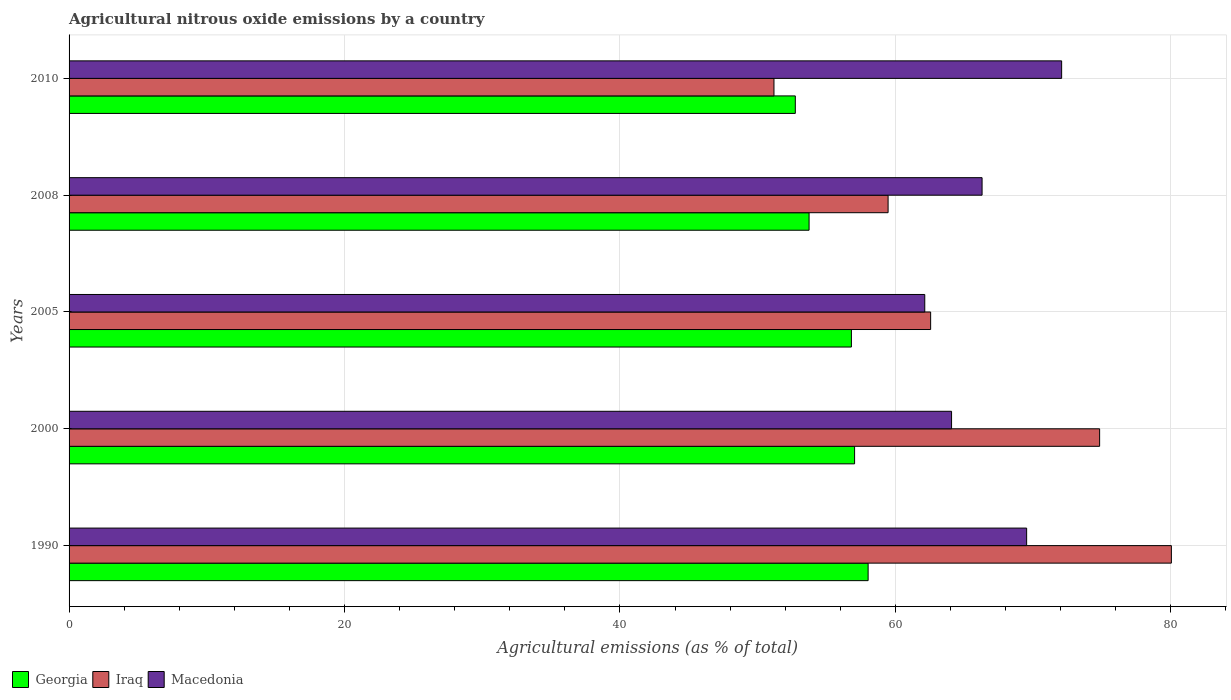How many groups of bars are there?
Keep it short and to the point. 5. Are the number of bars per tick equal to the number of legend labels?
Ensure brevity in your answer.  Yes. Are the number of bars on each tick of the Y-axis equal?
Keep it short and to the point. Yes. How many bars are there on the 3rd tick from the top?
Your answer should be compact. 3. How many bars are there on the 2nd tick from the bottom?
Ensure brevity in your answer.  3. What is the label of the 1st group of bars from the top?
Ensure brevity in your answer.  2010. What is the amount of agricultural nitrous oxide emitted in Iraq in 2000?
Offer a very short reply. 74.83. Across all years, what is the maximum amount of agricultural nitrous oxide emitted in Macedonia?
Make the answer very short. 72.07. Across all years, what is the minimum amount of agricultural nitrous oxide emitted in Macedonia?
Provide a succinct answer. 62.13. What is the total amount of agricultural nitrous oxide emitted in Georgia in the graph?
Your answer should be compact. 278.33. What is the difference between the amount of agricultural nitrous oxide emitted in Macedonia in 2000 and that in 2010?
Your answer should be very brief. -7.99. What is the difference between the amount of agricultural nitrous oxide emitted in Iraq in 2010 and the amount of agricultural nitrous oxide emitted in Georgia in 2000?
Offer a terse response. -5.85. What is the average amount of agricultural nitrous oxide emitted in Iraq per year?
Make the answer very short. 65.62. In the year 2000, what is the difference between the amount of agricultural nitrous oxide emitted in Georgia and amount of agricultural nitrous oxide emitted in Macedonia?
Provide a short and direct response. -7.04. In how many years, is the amount of agricultural nitrous oxide emitted in Macedonia greater than 56 %?
Keep it short and to the point. 5. What is the ratio of the amount of agricultural nitrous oxide emitted in Macedonia in 1990 to that in 2010?
Your answer should be very brief. 0.96. Is the amount of agricultural nitrous oxide emitted in Iraq in 1990 less than that in 2008?
Your response must be concise. No. What is the difference between the highest and the second highest amount of agricultural nitrous oxide emitted in Iraq?
Provide a succinct answer. 5.21. What is the difference between the highest and the lowest amount of agricultural nitrous oxide emitted in Iraq?
Offer a very short reply. 28.86. What does the 3rd bar from the top in 2000 represents?
Your answer should be compact. Georgia. What does the 2nd bar from the bottom in 2008 represents?
Your response must be concise. Iraq. How many bars are there?
Give a very brief answer. 15. Are all the bars in the graph horizontal?
Provide a short and direct response. Yes. Where does the legend appear in the graph?
Make the answer very short. Bottom left. How many legend labels are there?
Provide a succinct answer. 3. What is the title of the graph?
Your answer should be compact. Agricultural nitrous oxide emissions by a country. What is the label or title of the X-axis?
Offer a very short reply. Agricultural emissions (as % of total). What is the Agricultural emissions (as % of total) of Georgia in 1990?
Keep it short and to the point. 58.02. What is the Agricultural emissions (as % of total) in Iraq in 1990?
Keep it short and to the point. 80.04. What is the Agricultural emissions (as % of total) in Macedonia in 1990?
Give a very brief answer. 69.53. What is the Agricultural emissions (as % of total) in Georgia in 2000?
Provide a short and direct response. 57.04. What is the Agricultural emissions (as % of total) of Iraq in 2000?
Your answer should be compact. 74.83. What is the Agricultural emissions (as % of total) of Macedonia in 2000?
Provide a short and direct response. 64.08. What is the Agricultural emissions (as % of total) of Georgia in 2005?
Keep it short and to the point. 56.81. What is the Agricultural emissions (as % of total) of Iraq in 2005?
Give a very brief answer. 62.56. What is the Agricultural emissions (as % of total) of Macedonia in 2005?
Ensure brevity in your answer.  62.13. What is the Agricultural emissions (as % of total) in Georgia in 2008?
Provide a succinct answer. 53.73. What is the Agricultural emissions (as % of total) in Iraq in 2008?
Your response must be concise. 59.47. What is the Agricultural emissions (as % of total) in Macedonia in 2008?
Give a very brief answer. 66.29. What is the Agricultural emissions (as % of total) of Georgia in 2010?
Ensure brevity in your answer.  52.73. What is the Agricultural emissions (as % of total) of Iraq in 2010?
Your response must be concise. 51.18. What is the Agricultural emissions (as % of total) in Macedonia in 2010?
Offer a very short reply. 72.07. Across all years, what is the maximum Agricultural emissions (as % of total) in Georgia?
Provide a succinct answer. 58.02. Across all years, what is the maximum Agricultural emissions (as % of total) of Iraq?
Offer a very short reply. 80.04. Across all years, what is the maximum Agricultural emissions (as % of total) in Macedonia?
Ensure brevity in your answer.  72.07. Across all years, what is the minimum Agricultural emissions (as % of total) in Georgia?
Provide a short and direct response. 52.73. Across all years, what is the minimum Agricultural emissions (as % of total) in Iraq?
Your response must be concise. 51.18. Across all years, what is the minimum Agricultural emissions (as % of total) of Macedonia?
Offer a very short reply. 62.13. What is the total Agricultural emissions (as % of total) of Georgia in the graph?
Provide a short and direct response. 278.33. What is the total Agricultural emissions (as % of total) in Iraq in the graph?
Provide a short and direct response. 328.08. What is the total Agricultural emissions (as % of total) of Macedonia in the graph?
Your answer should be very brief. 334.11. What is the difference between the Agricultural emissions (as % of total) in Georgia in 1990 and that in 2000?
Your answer should be compact. 0.98. What is the difference between the Agricultural emissions (as % of total) in Iraq in 1990 and that in 2000?
Give a very brief answer. 5.21. What is the difference between the Agricultural emissions (as % of total) of Macedonia in 1990 and that in 2000?
Your answer should be compact. 5.45. What is the difference between the Agricultural emissions (as % of total) in Georgia in 1990 and that in 2005?
Offer a very short reply. 1.21. What is the difference between the Agricultural emissions (as % of total) in Iraq in 1990 and that in 2005?
Offer a very short reply. 17.48. What is the difference between the Agricultural emissions (as % of total) in Macedonia in 1990 and that in 2005?
Provide a short and direct response. 7.4. What is the difference between the Agricultural emissions (as % of total) in Georgia in 1990 and that in 2008?
Make the answer very short. 4.29. What is the difference between the Agricultural emissions (as % of total) of Iraq in 1990 and that in 2008?
Give a very brief answer. 20.57. What is the difference between the Agricultural emissions (as % of total) of Macedonia in 1990 and that in 2008?
Make the answer very short. 3.24. What is the difference between the Agricultural emissions (as % of total) in Georgia in 1990 and that in 2010?
Your answer should be very brief. 5.29. What is the difference between the Agricultural emissions (as % of total) in Iraq in 1990 and that in 2010?
Your response must be concise. 28.86. What is the difference between the Agricultural emissions (as % of total) in Macedonia in 1990 and that in 2010?
Provide a succinct answer. -2.54. What is the difference between the Agricultural emissions (as % of total) in Georgia in 2000 and that in 2005?
Your response must be concise. 0.23. What is the difference between the Agricultural emissions (as % of total) of Iraq in 2000 and that in 2005?
Provide a short and direct response. 12.27. What is the difference between the Agricultural emissions (as % of total) in Macedonia in 2000 and that in 2005?
Your response must be concise. 1.95. What is the difference between the Agricultural emissions (as % of total) in Georgia in 2000 and that in 2008?
Keep it short and to the point. 3.3. What is the difference between the Agricultural emissions (as % of total) of Iraq in 2000 and that in 2008?
Give a very brief answer. 15.36. What is the difference between the Agricultural emissions (as % of total) in Macedonia in 2000 and that in 2008?
Your answer should be compact. -2.22. What is the difference between the Agricultural emissions (as % of total) in Georgia in 2000 and that in 2010?
Keep it short and to the point. 4.3. What is the difference between the Agricultural emissions (as % of total) of Iraq in 2000 and that in 2010?
Your response must be concise. 23.65. What is the difference between the Agricultural emissions (as % of total) in Macedonia in 2000 and that in 2010?
Keep it short and to the point. -7.99. What is the difference between the Agricultural emissions (as % of total) of Georgia in 2005 and that in 2008?
Keep it short and to the point. 3.07. What is the difference between the Agricultural emissions (as % of total) of Iraq in 2005 and that in 2008?
Give a very brief answer. 3.09. What is the difference between the Agricultural emissions (as % of total) of Macedonia in 2005 and that in 2008?
Give a very brief answer. -4.16. What is the difference between the Agricultural emissions (as % of total) of Georgia in 2005 and that in 2010?
Give a very brief answer. 4.07. What is the difference between the Agricultural emissions (as % of total) in Iraq in 2005 and that in 2010?
Give a very brief answer. 11.38. What is the difference between the Agricultural emissions (as % of total) of Macedonia in 2005 and that in 2010?
Provide a short and direct response. -9.94. What is the difference between the Agricultural emissions (as % of total) in Georgia in 2008 and that in 2010?
Offer a terse response. 1. What is the difference between the Agricultural emissions (as % of total) of Iraq in 2008 and that in 2010?
Your answer should be compact. 8.29. What is the difference between the Agricultural emissions (as % of total) in Macedonia in 2008 and that in 2010?
Offer a terse response. -5.78. What is the difference between the Agricultural emissions (as % of total) of Georgia in 1990 and the Agricultural emissions (as % of total) of Iraq in 2000?
Give a very brief answer. -16.81. What is the difference between the Agricultural emissions (as % of total) of Georgia in 1990 and the Agricultural emissions (as % of total) of Macedonia in 2000?
Your response must be concise. -6.06. What is the difference between the Agricultural emissions (as % of total) in Iraq in 1990 and the Agricultural emissions (as % of total) in Macedonia in 2000?
Provide a succinct answer. 15.96. What is the difference between the Agricultural emissions (as % of total) of Georgia in 1990 and the Agricultural emissions (as % of total) of Iraq in 2005?
Your answer should be very brief. -4.54. What is the difference between the Agricultural emissions (as % of total) in Georgia in 1990 and the Agricultural emissions (as % of total) in Macedonia in 2005?
Your response must be concise. -4.11. What is the difference between the Agricultural emissions (as % of total) in Iraq in 1990 and the Agricultural emissions (as % of total) in Macedonia in 2005?
Provide a short and direct response. 17.91. What is the difference between the Agricultural emissions (as % of total) in Georgia in 1990 and the Agricultural emissions (as % of total) in Iraq in 2008?
Keep it short and to the point. -1.45. What is the difference between the Agricultural emissions (as % of total) in Georgia in 1990 and the Agricultural emissions (as % of total) in Macedonia in 2008?
Your answer should be compact. -8.28. What is the difference between the Agricultural emissions (as % of total) of Iraq in 1990 and the Agricultural emissions (as % of total) of Macedonia in 2008?
Give a very brief answer. 13.74. What is the difference between the Agricultural emissions (as % of total) of Georgia in 1990 and the Agricultural emissions (as % of total) of Iraq in 2010?
Provide a succinct answer. 6.84. What is the difference between the Agricultural emissions (as % of total) of Georgia in 1990 and the Agricultural emissions (as % of total) of Macedonia in 2010?
Offer a terse response. -14.05. What is the difference between the Agricultural emissions (as % of total) of Iraq in 1990 and the Agricultural emissions (as % of total) of Macedonia in 2010?
Offer a very short reply. 7.97. What is the difference between the Agricultural emissions (as % of total) in Georgia in 2000 and the Agricultural emissions (as % of total) in Iraq in 2005?
Make the answer very short. -5.52. What is the difference between the Agricultural emissions (as % of total) in Georgia in 2000 and the Agricultural emissions (as % of total) in Macedonia in 2005?
Make the answer very short. -5.1. What is the difference between the Agricultural emissions (as % of total) of Iraq in 2000 and the Agricultural emissions (as % of total) of Macedonia in 2005?
Make the answer very short. 12.7. What is the difference between the Agricultural emissions (as % of total) of Georgia in 2000 and the Agricultural emissions (as % of total) of Iraq in 2008?
Provide a short and direct response. -2.43. What is the difference between the Agricultural emissions (as % of total) of Georgia in 2000 and the Agricultural emissions (as % of total) of Macedonia in 2008?
Your answer should be very brief. -9.26. What is the difference between the Agricultural emissions (as % of total) of Iraq in 2000 and the Agricultural emissions (as % of total) of Macedonia in 2008?
Provide a short and direct response. 8.53. What is the difference between the Agricultural emissions (as % of total) of Georgia in 2000 and the Agricultural emissions (as % of total) of Iraq in 2010?
Offer a very short reply. 5.85. What is the difference between the Agricultural emissions (as % of total) in Georgia in 2000 and the Agricultural emissions (as % of total) in Macedonia in 2010?
Your response must be concise. -15.03. What is the difference between the Agricultural emissions (as % of total) in Iraq in 2000 and the Agricultural emissions (as % of total) in Macedonia in 2010?
Provide a succinct answer. 2.76. What is the difference between the Agricultural emissions (as % of total) of Georgia in 2005 and the Agricultural emissions (as % of total) of Iraq in 2008?
Make the answer very short. -2.66. What is the difference between the Agricultural emissions (as % of total) of Georgia in 2005 and the Agricultural emissions (as % of total) of Macedonia in 2008?
Your answer should be compact. -9.49. What is the difference between the Agricultural emissions (as % of total) of Iraq in 2005 and the Agricultural emissions (as % of total) of Macedonia in 2008?
Your answer should be very brief. -3.74. What is the difference between the Agricultural emissions (as % of total) of Georgia in 2005 and the Agricultural emissions (as % of total) of Iraq in 2010?
Your answer should be compact. 5.62. What is the difference between the Agricultural emissions (as % of total) of Georgia in 2005 and the Agricultural emissions (as % of total) of Macedonia in 2010?
Your response must be concise. -15.27. What is the difference between the Agricultural emissions (as % of total) in Iraq in 2005 and the Agricultural emissions (as % of total) in Macedonia in 2010?
Offer a terse response. -9.51. What is the difference between the Agricultural emissions (as % of total) in Georgia in 2008 and the Agricultural emissions (as % of total) in Iraq in 2010?
Provide a succinct answer. 2.55. What is the difference between the Agricultural emissions (as % of total) of Georgia in 2008 and the Agricultural emissions (as % of total) of Macedonia in 2010?
Keep it short and to the point. -18.34. What is the difference between the Agricultural emissions (as % of total) in Iraq in 2008 and the Agricultural emissions (as % of total) in Macedonia in 2010?
Your response must be concise. -12.6. What is the average Agricultural emissions (as % of total) in Georgia per year?
Offer a very short reply. 55.67. What is the average Agricultural emissions (as % of total) of Iraq per year?
Give a very brief answer. 65.62. What is the average Agricultural emissions (as % of total) of Macedonia per year?
Offer a very short reply. 66.82. In the year 1990, what is the difference between the Agricultural emissions (as % of total) in Georgia and Agricultural emissions (as % of total) in Iraq?
Make the answer very short. -22.02. In the year 1990, what is the difference between the Agricultural emissions (as % of total) of Georgia and Agricultural emissions (as % of total) of Macedonia?
Keep it short and to the point. -11.51. In the year 1990, what is the difference between the Agricultural emissions (as % of total) of Iraq and Agricultural emissions (as % of total) of Macedonia?
Provide a succinct answer. 10.51. In the year 2000, what is the difference between the Agricultural emissions (as % of total) of Georgia and Agricultural emissions (as % of total) of Iraq?
Provide a short and direct response. -17.79. In the year 2000, what is the difference between the Agricultural emissions (as % of total) of Georgia and Agricultural emissions (as % of total) of Macedonia?
Your answer should be very brief. -7.04. In the year 2000, what is the difference between the Agricultural emissions (as % of total) of Iraq and Agricultural emissions (as % of total) of Macedonia?
Provide a short and direct response. 10.75. In the year 2005, what is the difference between the Agricultural emissions (as % of total) of Georgia and Agricultural emissions (as % of total) of Iraq?
Provide a short and direct response. -5.75. In the year 2005, what is the difference between the Agricultural emissions (as % of total) in Georgia and Agricultural emissions (as % of total) in Macedonia?
Make the answer very short. -5.33. In the year 2005, what is the difference between the Agricultural emissions (as % of total) of Iraq and Agricultural emissions (as % of total) of Macedonia?
Your response must be concise. 0.43. In the year 2008, what is the difference between the Agricultural emissions (as % of total) of Georgia and Agricultural emissions (as % of total) of Iraq?
Ensure brevity in your answer.  -5.74. In the year 2008, what is the difference between the Agricultural emissions (as % of total) in Georgia and Agricultural emissions (as % of total) in Macedonia?
Keep it short and to the point. -12.56. In the year 2008, what is the difference between the Agricultural emissions (as % of total) in Iraq and Agricultural emissions (as % of total) in Macedonia?
Offer a terse response. -6.82. In the year 2010, what is the difference between the Agricultural emissions (as % of total) of Georgia and Agricultural emissions (as % of total) of Iraq?
Offer a very short reply. 1.55. In the year 2010, what is the difference between the Agricultural emissions (as % of total) of Georgia and Agricultural emissions (as % of total) of Macedonia?
Give a very brief answer. -19.34. In the year 2010, what is the difference between the Agricultural emissions (as % of total) of Iraq and Agricultural emissions (as % of total) of Macedonia?
Your response must be concise. -20.89. What is the ratio of the Agricultural emissions (as % of total) of Georgia in 1990 to that in 2000?
Offer a terse response. 1.02. What is the ratio of the Agricultural emissions (as % of total) of Iraq in 1990 to that in 2000?
Ensure brevity in your answer.  1.07. What is the ratio of the Agricultural emissions (as % of total) of Macedonia in 1990 to that in 2000?
Give a very brief answer. 1.09. What is the ratio of the Agricultural emissions (as % of total) in Georgia in 1990 to that in 2005?
Offer a very short reply. 1.02. What is the ratio of the Agricultural emissions (as % of total) in Iraq in 1990 to that in 2005?
Keep it short and to the point. 1.28. What is the ratio of the Agricultural emissions (as % of total) in Macedonia in 1990 to that in 2005?
Your response must be concise. 1.12. What is the ratio of the Agricultural emissions (as % of total) in Georgia in 1990 to that in 2008?
Provide a short and direct response. 1.08. What is the ratio of the Agricultural emissions (as % of total) in Iraq in 1990 to that in 2008?
Provide a succinct answer. 1.35. What is the ratio of the Agricultural emissions (as % of total) of Macedonia in 1990 to that in 2008?
Ensure brevity in your answer.  1.05. What is the ratio of the Agricultural emissions (as % of total) of Georgia in 1990 to that in 2010?
Offer a terse response. 1.1. What is the ratio of the Agricultural emissions (as % of total) of Iraq in 1990 to that in 2010?
Provide a succinct answer. 1.56. What is the ratio of the Agricultural emissions (as % of total) in Macedonia in 1990 to that in 2010?
Provide a succinct answer. 0.96. What is the ratio of the Agricultural emissions (as % of total) in Georgia in 2000 to that in 2005?
Your answer should be very brief. 1. What is the ratio of the Agricultural emissions (as % of total) in Iraq in 2000 to that in 2005?
Ensure brevity in your answer.  1.2. What is the ratio of the Agricultural emissions (as % of total) in Macedonia in 2000 to that in 2005?
Give a very brief answer. 1.03. What is the ratio of the Agricultural emissions (as % of total) of Georgia in 2000 to that in 2008?
Offer a very short reply. 1.06. What is the ratio of the Agricultural emissions (as % of total) in Iraq in 2000 to that in 2008?
Your response must be concise. 1.26. What is the ratio of the Agricultural emissions (as % of total) of Macedonia in 2000 to that in 2008?
Keep it short and to the point. 0.97. What is the ratio of the Agricultural emissions (as % of total) in Georgia in 2000 to that in 2010?
Give a very brief answer. 1.08. What is the ratio of the Agricultural emissions (as % of total) of Iraq in 2000 to that in 2010?
Provide a short and direct response. 1.46. What is the ratio of the Agricultural emissions (as % of total) of Macedonia in 2000 to that in 2010?
Give a very brief answer. 0.89. What is the ratio of the Agricultural emissions (as % of total) of Georgia in 2005 to that in 2008?
Provide a short and direct response. 1.06. What is the ratio of the Agricultural emissions (as % of total) in Iraq in 2005 to that in 2008?
Offer a very short reply. 1.05. What is the ratio of the Agricultural emissions (as % of total) in Macedonia in 2005 to that in 2008?
Your answer should be very brief. 0.94. What is the ratio of the Agricultural emissions (as % of total) in Georgia in 2005 to that in 2010?
Offer a terse response. 1.08. What is the ratio of the Agricultural emissions (as % of total) of Iraq in 2005 to that in 2010?
Your answer should be compact. 1.22. What is the ratio of the Agricultural emissions (as % of total) of Macedonia in 2005 to that in 2010?
Your response must be concise. 0.86. What is the ratio of the Agricultural emissions (as % of total) in Georgia in 2008 to that in 2010?
Provide a short and direct response. 1.02. What is the ratio of the Agricultural emissions (as % of total) in Iraq in 2008 to that in 2010?
Make the answer very short. 1.16. What is the ratio of the Agricultural emissions (as % of total) of Macedonia in 2008 to that in 2010?
Your answer should be compact. 0.92. What is the difference between the highest and the second highest Agricultural emissions (as % of total) in Georgia?
Keep it short and to the point. 0.98. What is the difference between the highest and the second highest Agricultural emissions (as % of total) of Iraq?
Ensure brevity in your answer.  5.21. What is the difference between the highest and the second highest Agricultural emissions (as % of total) in Macedonia?
Your response must be concise. 2.54. What is the difference between the highest and the lowest Agricultural emissions (as % of total) of Georgia?
Keep it short and to the point. 5.29. What is the difference between the highest and the lowest Agricultural emissions (as % of total) in Iraq?
Offer a terse response. 28.86. What is the difference between the highest and the lowest Agricultural emissions (as % of total) of Macedonia?
Keep it short and to the point. 9.94. 